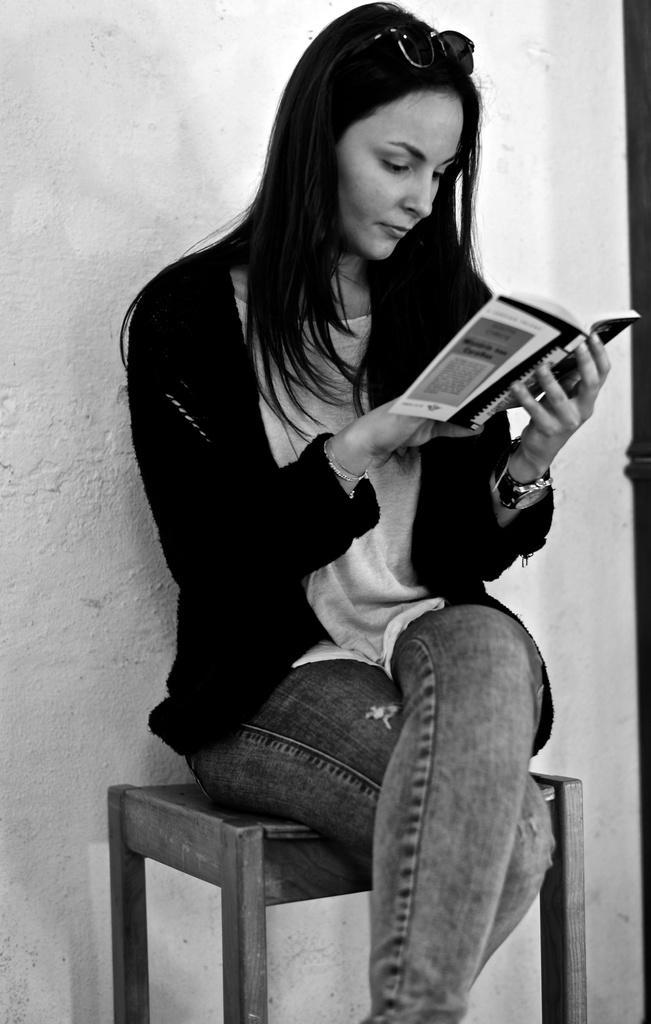Please provide a concise description of this image. In this image there is a woman sitting on a stool, she is reading a book, she is wearing a goggles, at the background of the image there is the wall. 